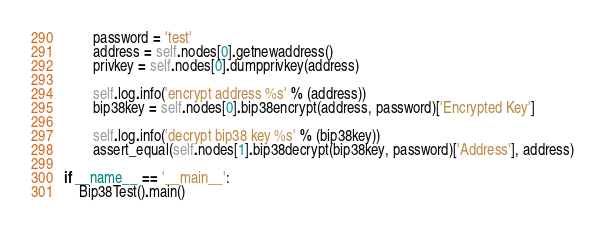<code> <loc_0><loc_0><loc_500><loc_500><_Python_>        password = 'test'
        address = self.nodes[0].getnewaddress()
        privkey = self.nodes[0].dumpprivkey(address)

        self.log.info('encrypt address %s' % (address))
        bip38key = self.nodes[0].bip38encrypt(address, password)['Encrypted Key']

        self.log.info('decrypt bip38 key %s' % (bip38key))
        assert_equal(self.nodes[1].bip38decrypt(bip38key, password)['Address'], address)

if __name__ == '__main__':
    Bip38Test().main()
</code> 